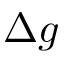<formula> <loc_0><loc_0><loc_500><loc_500>\Delta g</formula> 